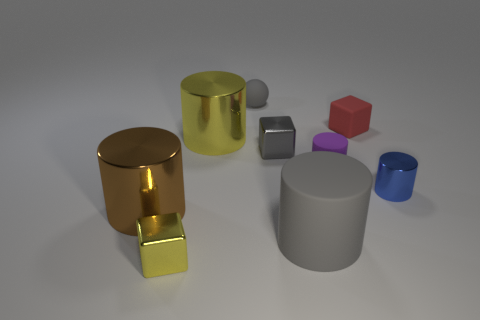What shape is the red matte object that is the same size as the blue thing?
Provide a succinct answer. Cube. Do the cylinder left of the small yellow shiny object and the large cylinder that is in front of the brown cylinder have the same material?
Your response must be concise. No. What is the material of the brown object in front of the metal cylinder right of the rubber sphere?
Offer a very short reply. Metal. What is the size of the gray rubber thing that is behind the small shiny object that is on the right side of the small red thing that is on the right side of the big brown object?
Make the answer very short. Small. Does the brown shiny cylinder have the same size as the red thing?
Your answer should be compact. No. There is a large brown thing in front of the blue shiny object; does it have the same shape as the big metal object that is right of the big brown cylinder?
Make the answer very short. Yes. Are there any red cubes that are behind the tiny red block behind the tiny metal cylinder?
Keep it short and to the point. No. Are there any small gray matte objects?
Your response must be concise. Yes. What number of cyan balls are the same size as the matte cube?
Ensure brevity in your answer.  0. How many tiny shiny things are both in front of the gray metal object and behind the large gray thing?
Ensure brevity in your answer.  1. 